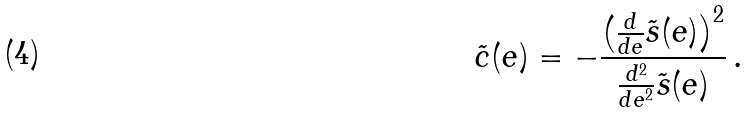<formula> <loc_0><loc_0><loc_500><loc_500>\tilde { c } ( e ) = - \frac { \left ( \frac { d } { d e } \tilde { s } ( e ) \right ) ^ { 2 } } { \frac { d ^ { 2 } } { d e ^ { 2 } } \tilde { s } ( e ) } \, .</formula> 